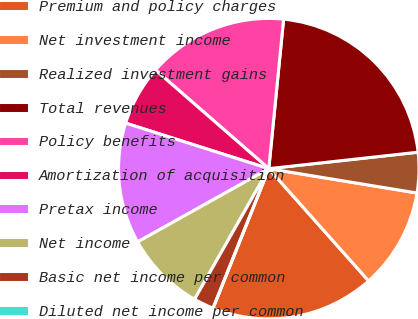Convert chart. <chart><loc_0><loc_0><loc_500><loc_500><pie_chart><fcel>Premium and policy charges<fcel>Net investment income<fcel>Realized investment gains<fcel>Total revenues<fcel>Policy benefits<fcel>Amortization of acquisition<fcel>Pretax income<fcel>Net income<fcel>Basic net income per common<fcel>Diluted net income per common<nl><fcel>17.62%<fcel>10.84%<fcel>4.34%<fcel>21.68%<fcel>15.17%<fcel>6.5%<fcel>13.01%<fcel>8.67%<fcel>2.17%<fcel>0.0%<nl></chart> 